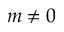Convert formula to latex. <formula><loc_0><loc_0><loc_500><loc_500>m \ne 0</formula> 